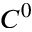<formula> <loc_0><loc_0><loc_500><loc_500>C ^ { 0 }</formula> 